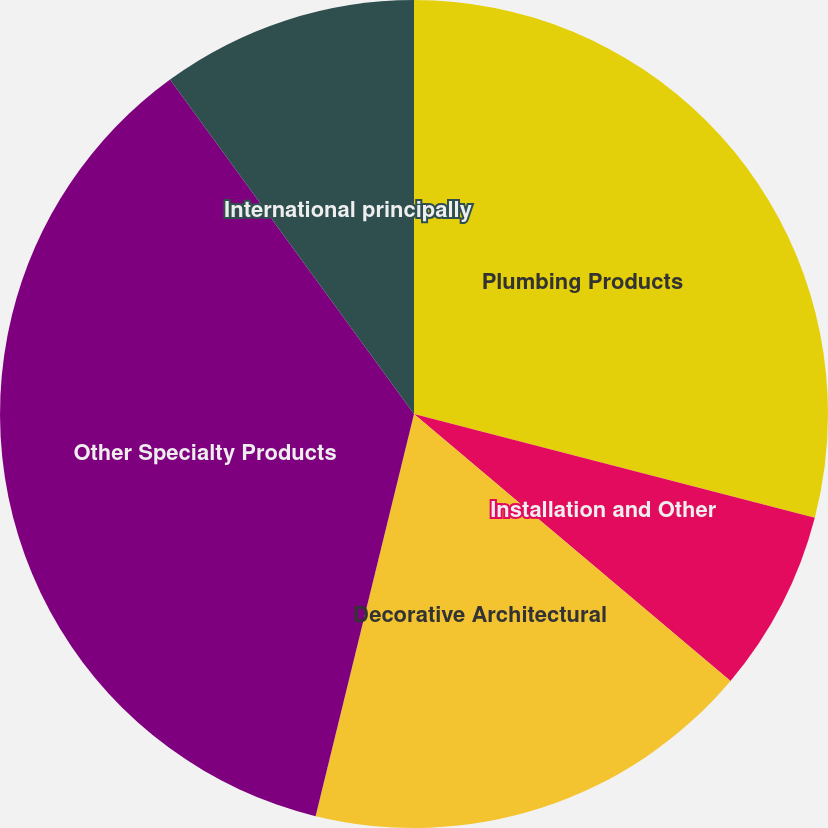Convert chart to OTSL. <chart><loc_0><loc_0><loc_500><loc_500><pie_chart><fcel>Plumbing Products<fcel>Installation and Other<fcel>Decorative Architectural<fcel>Other Specialty Products<fcel>International principally<nl><fcel>29.03%<fcel>7.12%<fcel>17.67%<fcel>36.15%<fcel>10.03%<nl></chart> 